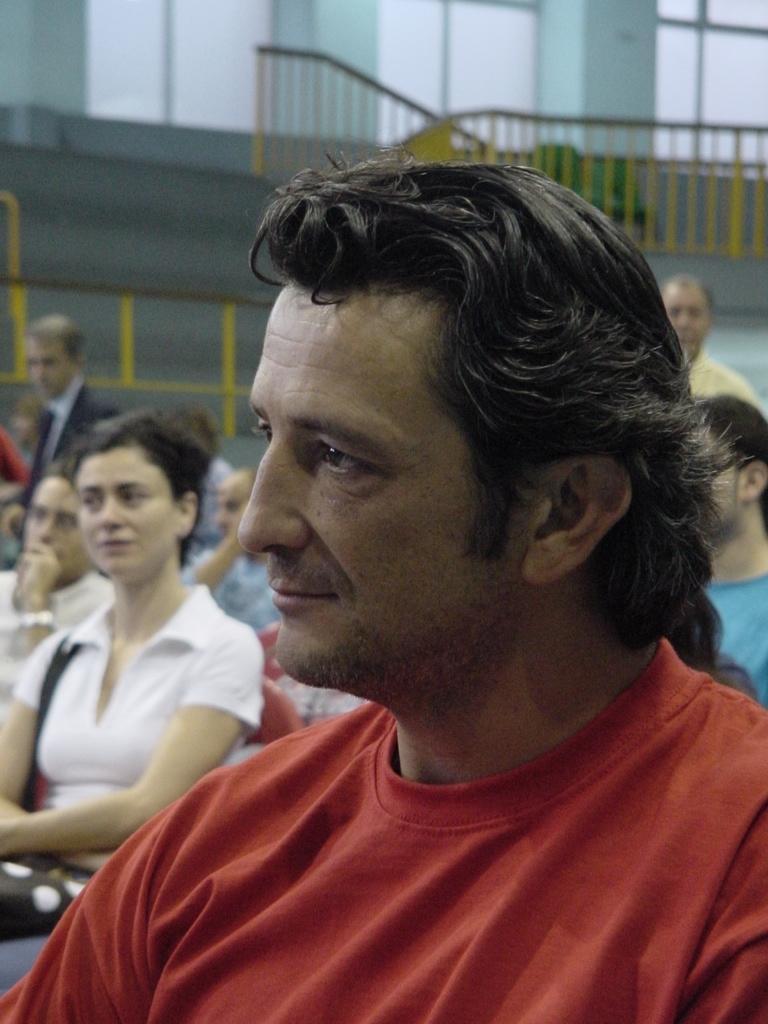In one or two sentences, can you explain what this image depicts? In this image we can see a man is sitting. He is wearing a T-shirt. In the background, we can see people are standing and sitting. At the top of the image, we can see railing, wall and windows. 